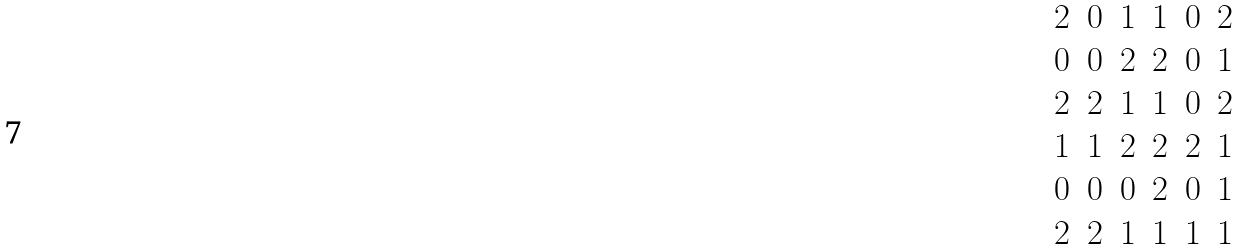<formula> <loc_0><loc_0><loc_500><loc_500>\begin{matrix} 2 & 0 & 1 & 1 & 0 & 2 \\ 0 & 0 & 2 & 2 & 0 & 1 \\ 2 & 2 & 1 & 1 & 0 & 2 \\ 1 & 1 & 2 & 2 & 2 & 1 \\ 0 & 0 & 0 & 2 & 0 & 1 \\ 2 & 2 & 1 & 1 & 1 & 1 \end{matrix}</formula> 